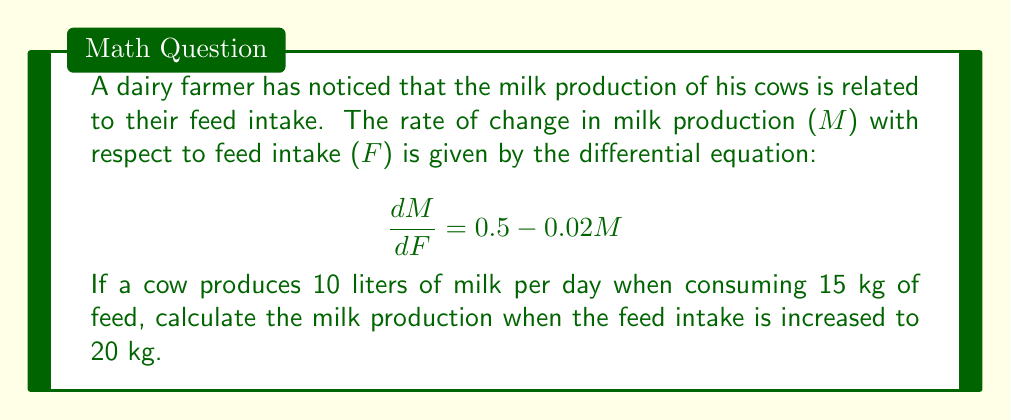Could you help me with this problem? To solve this problem, we need to use the given differential equation and initial condition to find the milk production at the new feed intake level. Let's approach this step-by-step:

1) First, we rearrange the differential equation:
   $$ \frac{dM}{dF} + 0.02M = 0.5 $$

2) This is a first-order linear differential equation. The general solution is:
   $$ M = 25 + Ce^{-0.02F} $$
   where C is a constant of integration.

3) We can find C using the initial condition: M = 10 when F = 15
   $$ 10 = 25 + Ce^{-0.02(15)} $$
   $$ C = (10 - 25)e^{0.3} = -15e^{0.3} $$

4) Now we have the particular solution:
   $$ M = 25 - 15e^{0.3}e^{-0.02F} $$

5) To find the milk production when F = 20, we substitute this value:
   $$ M = 25 - 15e^{0.3}e^{-0.02(20)} $$
   $$ M = 25 - 15e^{0.3-0.4} $$
   $$ M = 25 - 15e^{-0.1} $$

6) Calculating this value:
   $$ M \approx 25 - 15(0.9048) \approx 11.43 $$

Therefore, when the feed intake is increased to 20 kg, the milk production will be approximately 11.43 liters per day.
Answer: The milk production when feed intake is increased to 20 kg is approximately 11.43 liters per day. 